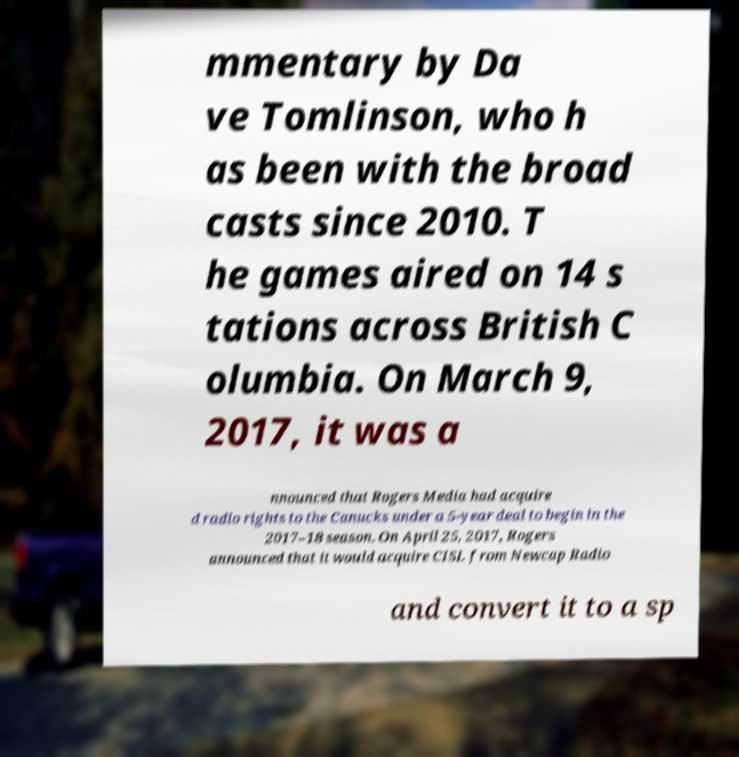Could you extract and type out the text from this image? mmentary by Da ve Tomlinson, who h as been with the broad casts since 2010. T he games aired on 14 s tations across British C olumbia. On March 9, 2017, it was a nnounced that Rogers Media had acquire d radio rights to the Canucks under a 5-year deal to begin in the 2017–18 season. On April 25, 2017, Rogers announced that it would acquire CISL from Newcap Radio and convert it to a sp 